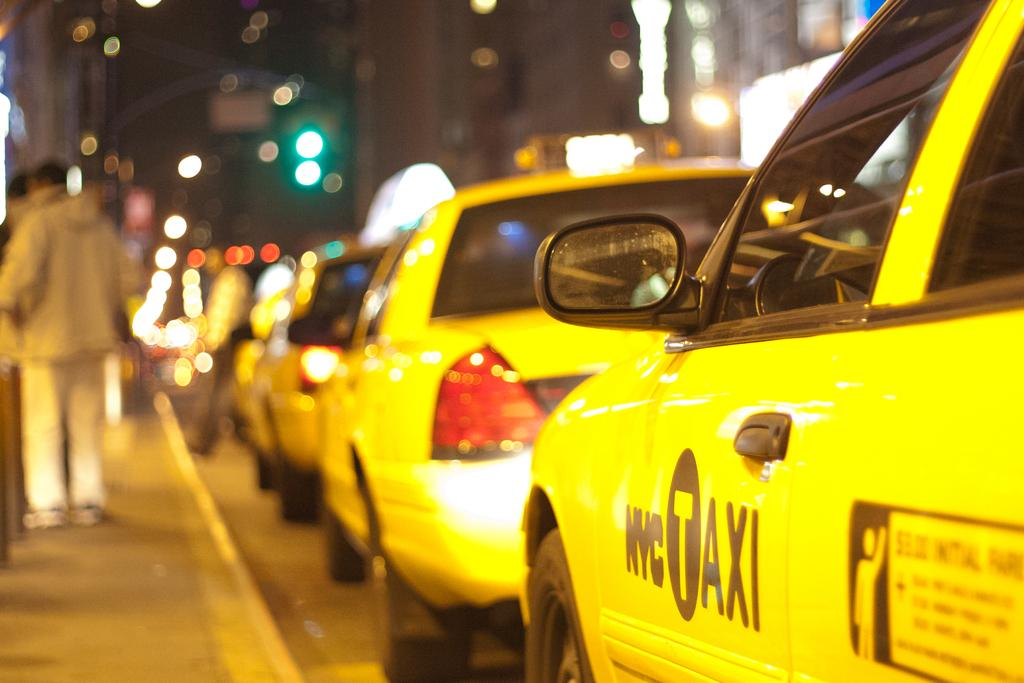<image>
Present a compact description of the photo's key features. A line of NYC yellow taxis at a sidewalk curb. 